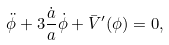<formula> <loc_0><loc_0><loc_500><loc_500>\ddot { \phi } + 3 \frac { \dot { a } } { a } \dot { \phi } + \bar { V } ^ { \prime } ( \phi ) = 0 ,</formula> 